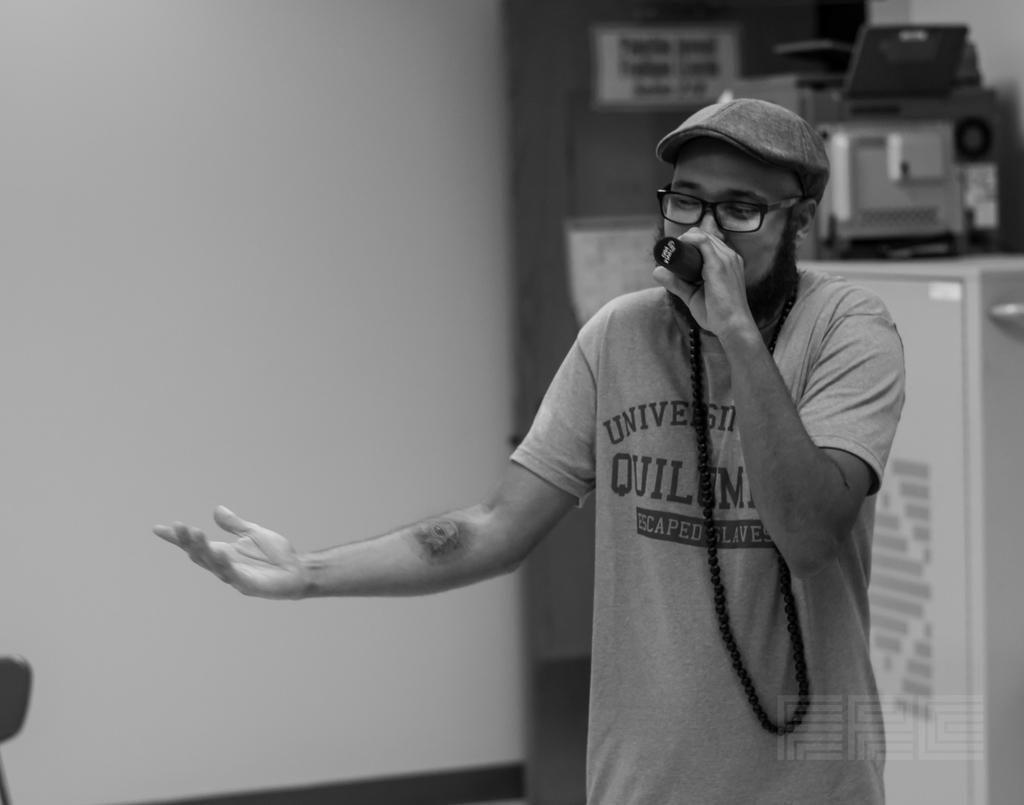What is the person in the image doing? The person is singing. What is the person holding while singing? The person is holding a microphone. Can you describe the background of the image? There are objects visible in the background of the image. What degree does the person in the image have in singing? The provided facts do not mention any degree or qualification related to the person's singing ability. 